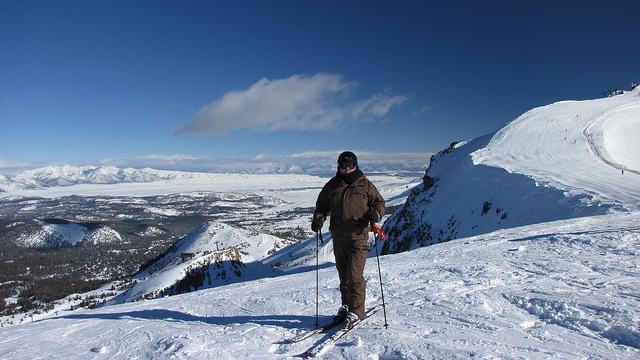How many zebras are facing forward?
Give a very brief answer. 0. 